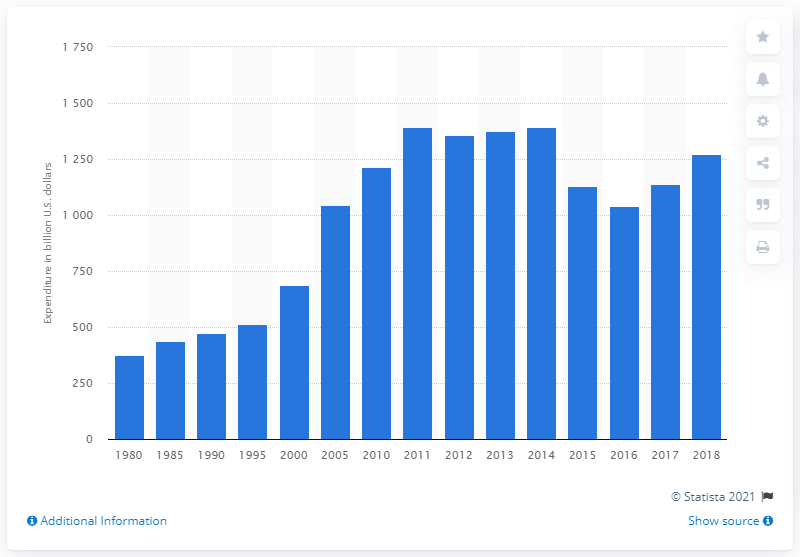Specify some key components in this picture. The total spending on energy in the United States in 2018 was 1271.06. In the United States, the total spending on energy in the previous year was 1136.5. 